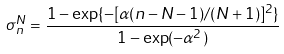Convert formula to latex. <formula><loc_0><loc_0><loc_500><loc_500>\sigma _ { n } ^ { N } = \frac { 1 - \exp \{ - [ \alpha ( n - N - 1 ) / ( N + 1 ) ] ^ { 2 } \} } { 1 - \exp ( - \alpha ^ { 2 } ) }</formula> 